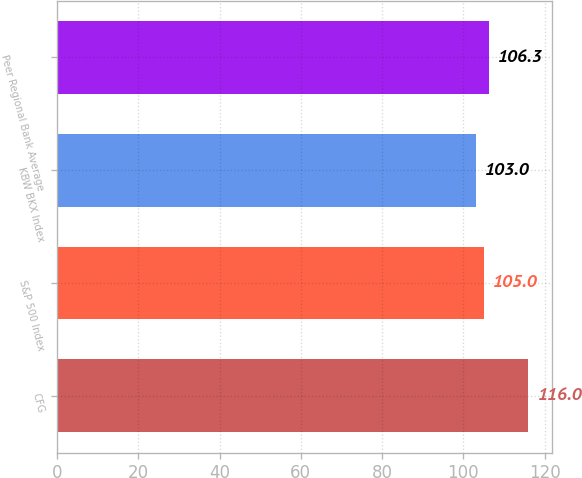Convert chart. <chart><loc_0><loc_0><loc_500><loc_500><bar_chart><fcel>CFG<fcel>S&P 500 Index<fcel>KBW BKX Index<fcel>Peer Regional Bank Average<nl><fcel>116<fcel>105<fcel>103<fcel>106.3<nl></chart> 